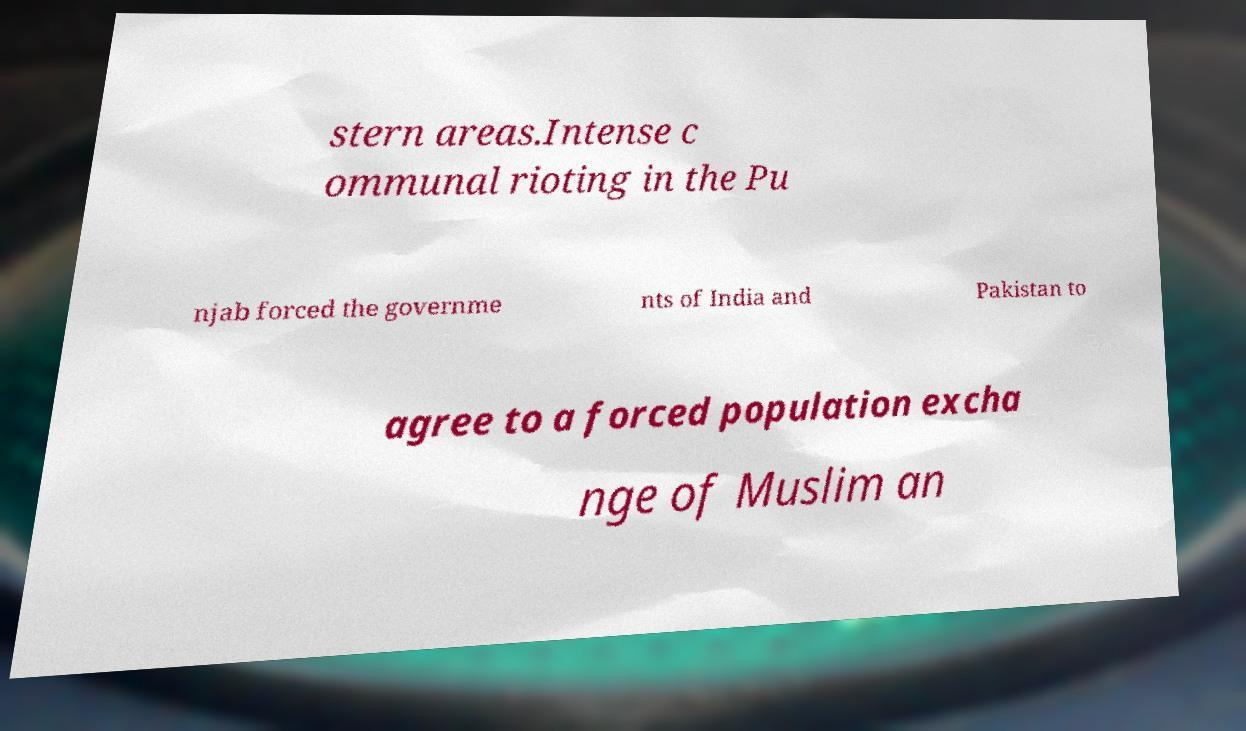Please read and relay the text visible in this image. What does it say? stern areas.Intense c ommunal rioting in the Pu njab forced the governme nts of India and Pakistan to agree to a forced population excha nge of Muslim an 